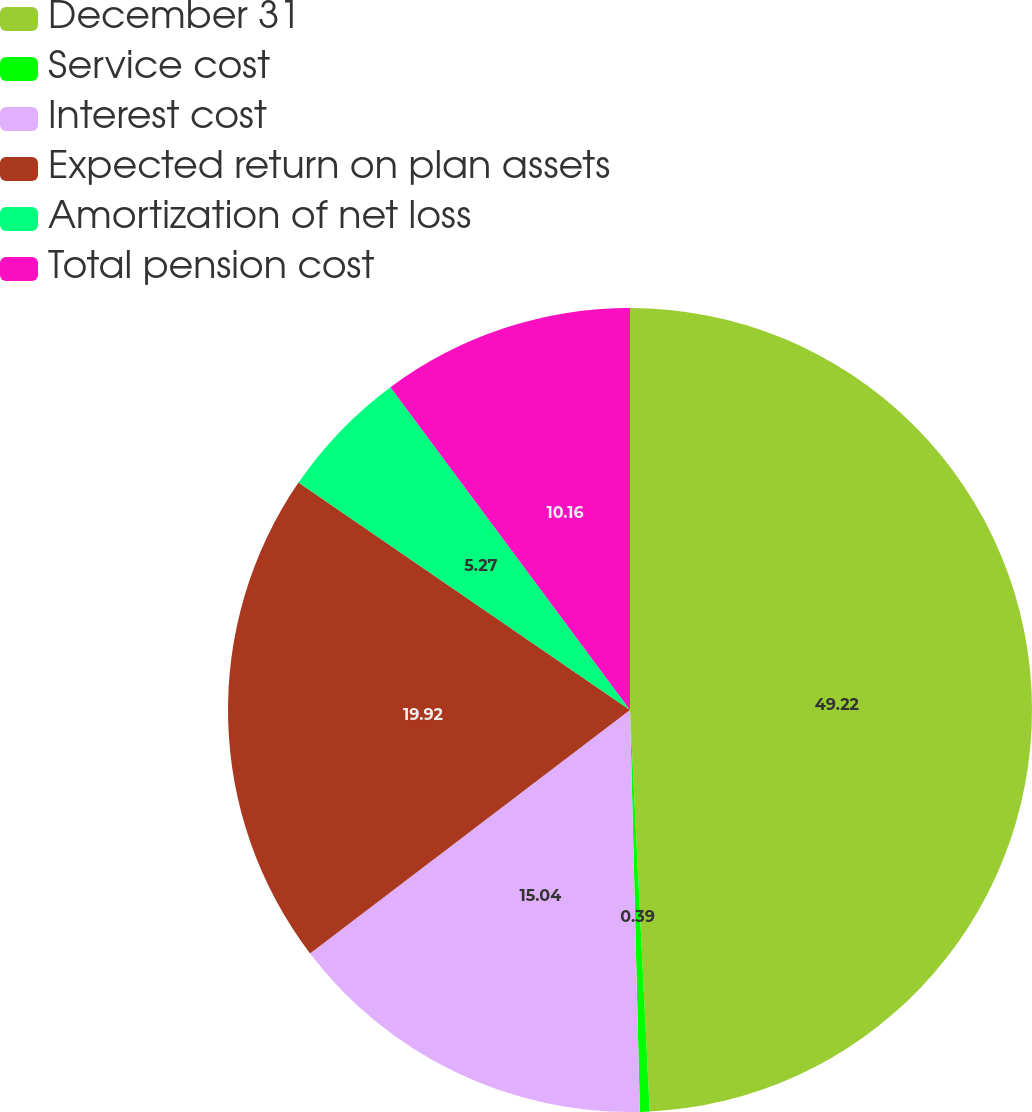<chart> <loc_0><loc_0><loc_500><loc_500><pie_chart><fcel>December 31<fcel>Service cost<fcel>Interest cost<fcel>Expected return on plan assets<fcel>Amortization of net loss<fcel>Total pension cost<nl><fcel>49.22%<fcel>0.39%<fcel>15.04%<fcel>19.92%<fcel>5.27%<fcel>10.16%<nl></chart> 